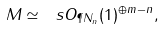<formula> <loc_0><loc_0><loc_500><loc_500>M \simeq \ s O _ { \P N _ { n } } ( 1 ) ^ { \oplus m - n } ,</formula> 